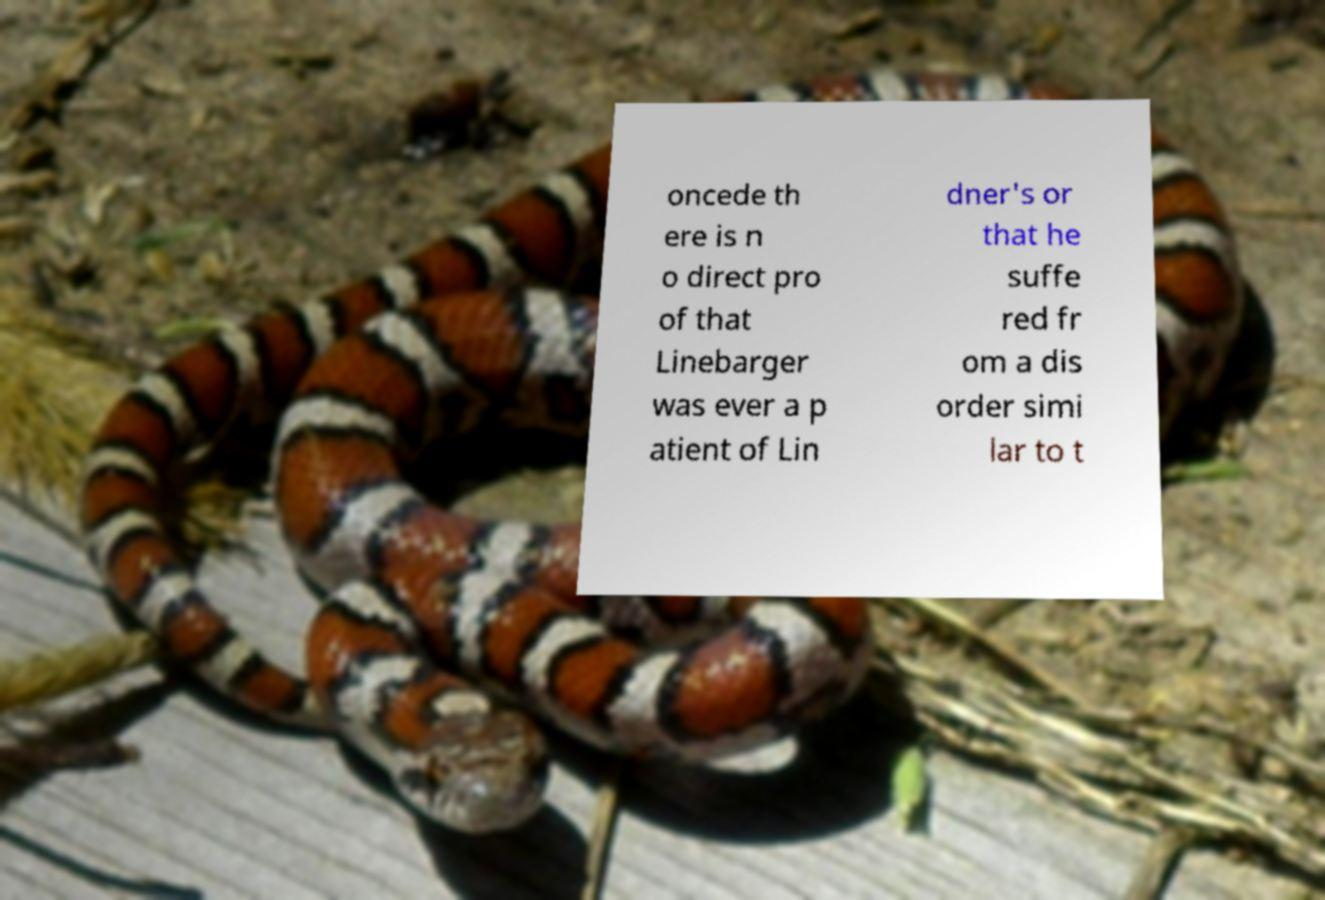Can you accurately transcribe the text from the provided image for me? oncede th ere is n o direct pro of that Linebarger was ever a p atient of Lin dner's or that he suffe red fr om a dis order simi lar to t 